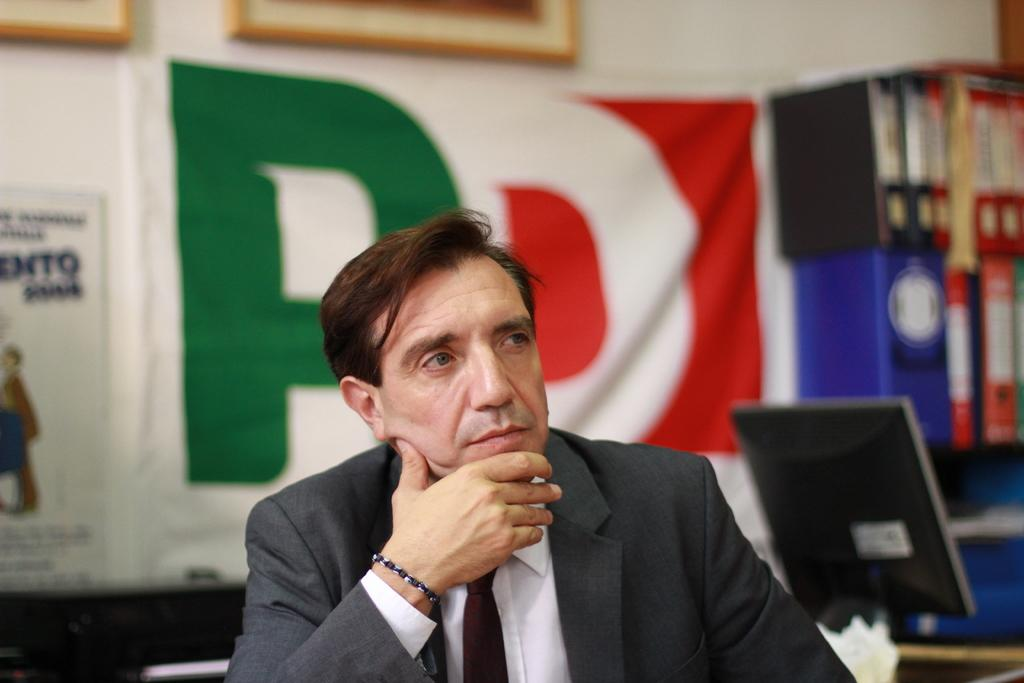What is the main subject of the image? There is a person in the image. What can be seen in the background of the image? There are objects in the background of the image. How would you describe the appearance of the background? The background of the image is blurry. What type of canvas is the person painting in the image? There is no canvas or painting activity present in the image. 